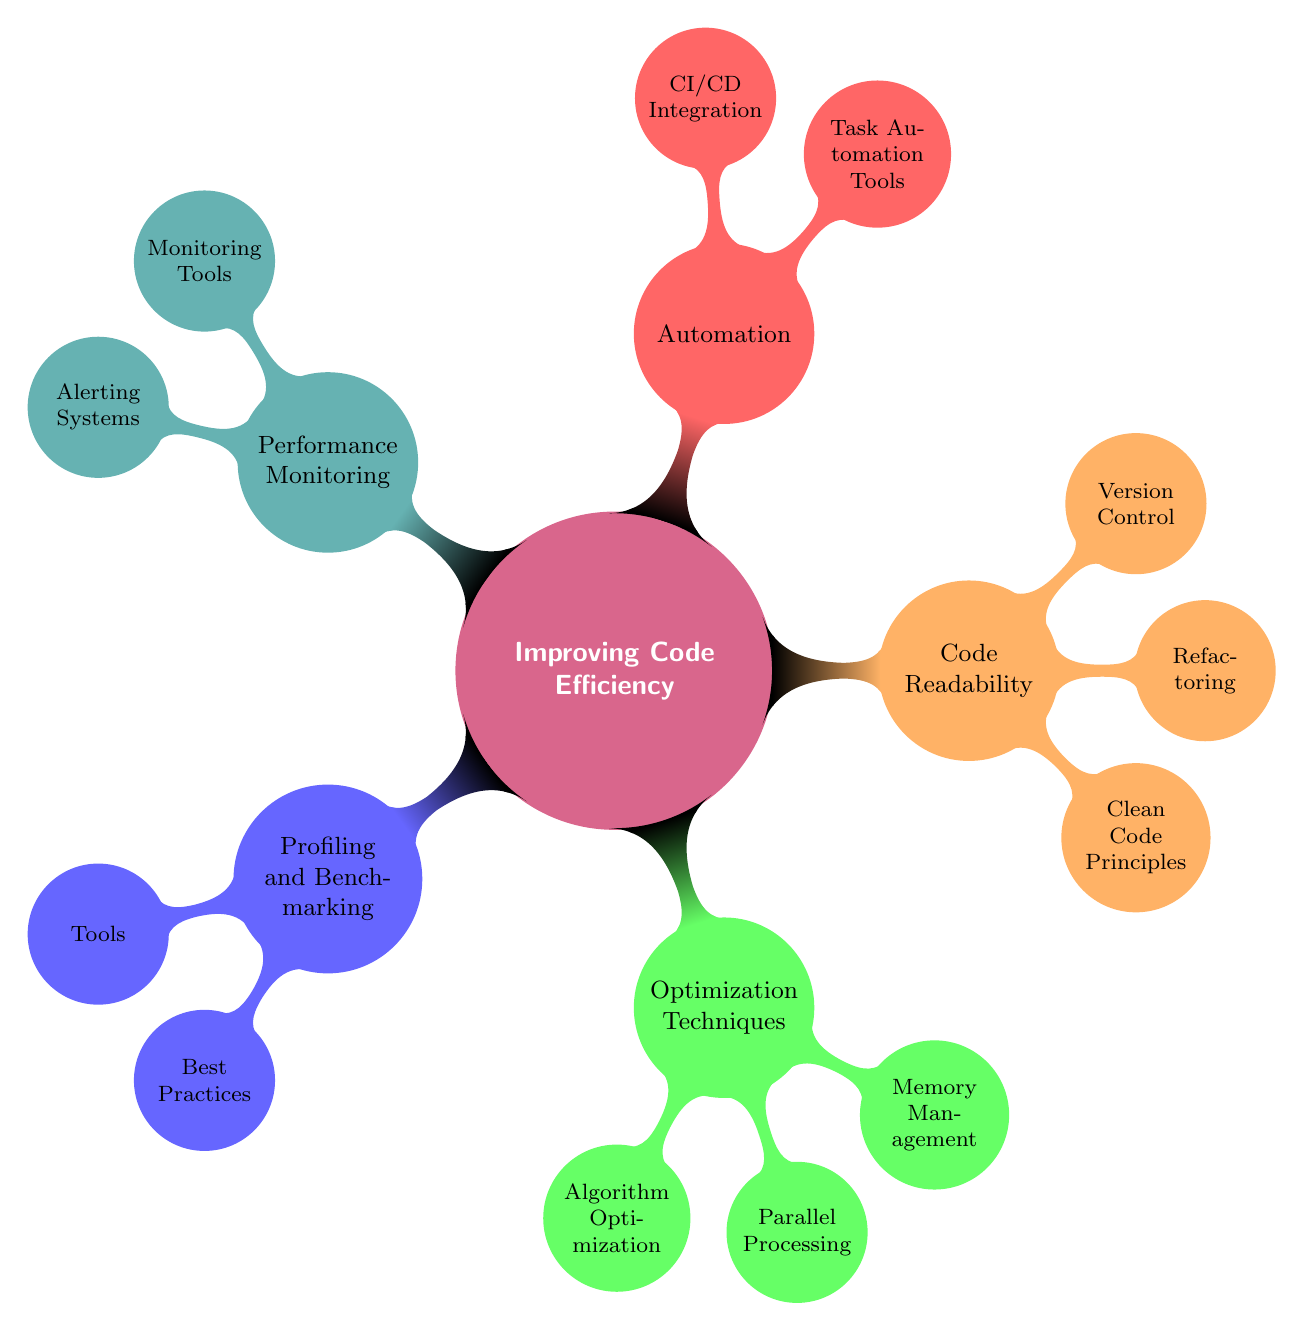What is the main topic of the mind map? The center of the mind map displays the main topic, which is "Improving Code Efficiency."
Answer: Improving Code Efficiency How many main branches does the diagram have? By counting the branches radiating from the central topic, we see there are five main branches: Profiling and Benchmarking, Optimization Techniques, Code Readability and Maintenance, Automation, and Performance Monitoring.
Answer: Five What are the two techniques under Automation? Looking under the Automation branch, we find two techniques listed: Task Automation Tools and CI/CD Integration.
Answer: Task Automation Tools and CI/CD Integration Which tool is mentioned under Profiling and Benchmarking? By checking the tools listed under the Profiling and Benchmarking branch, we see that "cProfile" is one of the mentioned tools.
Answer: cProfile What is a best practice in Profiling and Benchmarking? When examining the Best Practices node under Profiling and Benchmarking, we find the practice "Identify bottlenecks."
Answer: Identify bottlenecks What category do "Multiprocessing with concurrent.futures" and "Using joblib for parallel loops" belong to? Reviewing the branches, these two items are listed under the "Parallel Processing" node, which is part of the "Optimization Techniques" category.
Answer: Parallel Processing What is one of the Clean Code Principles? Under the Clean Code Principles branch, a specific principle mentioned is "Follow PEP8 guidelines."
Answer: Follow PEP8 guidelines What alerting system is connected to Performance Monitoring? In the Performance Monitoring branch, one of the alerting systems listed is "Email notifications."
Answer: Email notifications How many optimization techniques are listed in the diagram? By examining the "Optimization Techniques" branch, we see there are three techniques mentioned: Algorithm Optimization, Parallel Processing, and Memory Management.
Answer: Three 